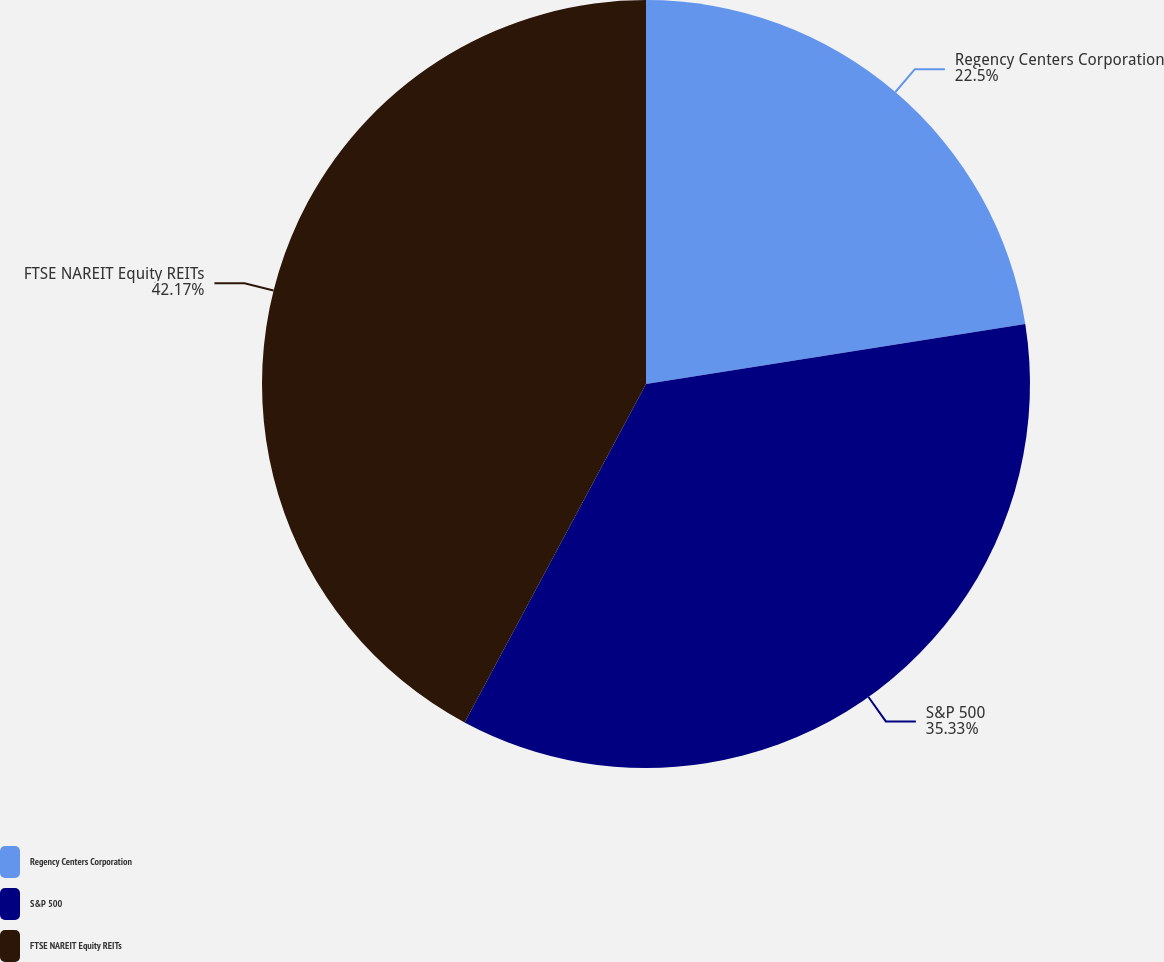Convert chart to OTSL. <chart><loc_0><loc_0><loc_500><loc_500><pie_chart><fcel>Regency Centers Corporation<fcel>S&P 500<fcel>FTSE NAREIT Equity REITs<nl><fcel>22.5%<fcel>35.33%<fcel>42.17%<nl></chart> 